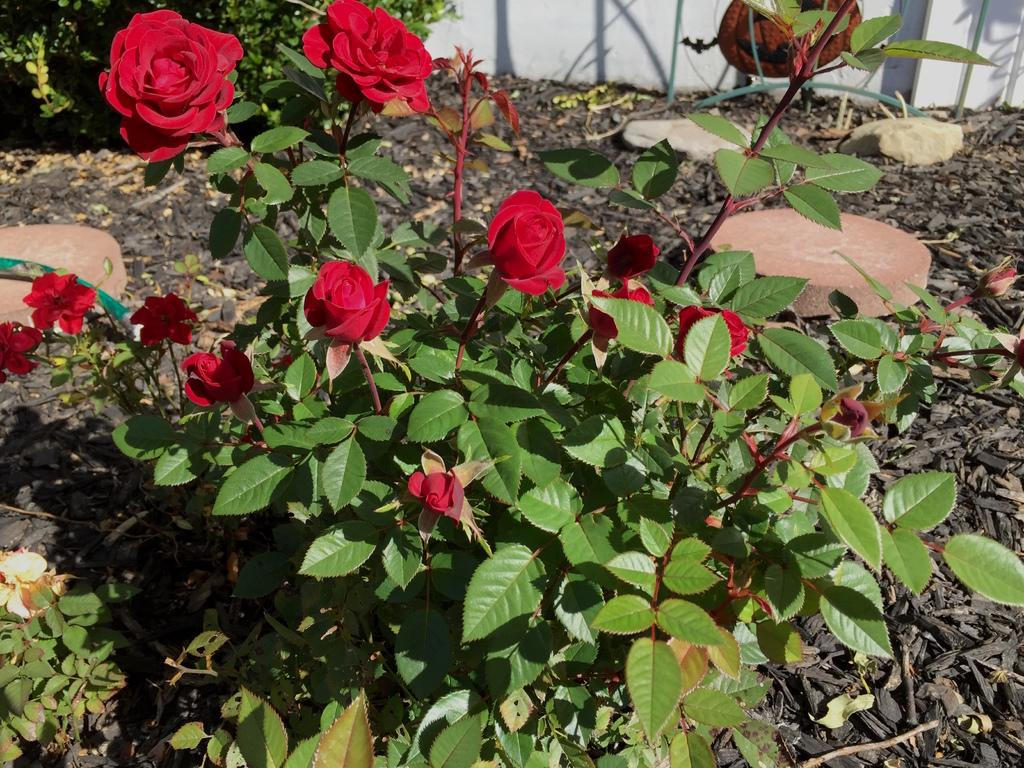What type of plants can be seen in the image? There are plants with flowers in the image. What can be found on the ground in the image? There are shredded leaves on the ground in the image. What type of cup is being used as bait in the image? There is no cup or bait present in the image; it features plants with flowers and shredded leaves on the ground. 